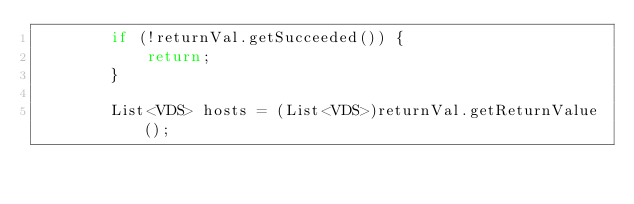<code> <loc_0><loc_0><loc_500><loc_500><_Java_>        if (!returnVal.getSucceeded()) {
            return;
        }

        List<VDS> hosts = (List<VDS>)returnVal.getReturnValue();
</code> 